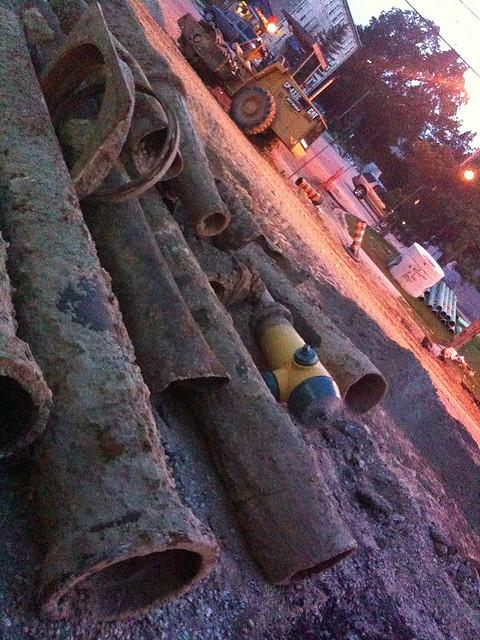What type of site is this?

Choices:
A) burial
B) historical
C) religious
D) construction construction 